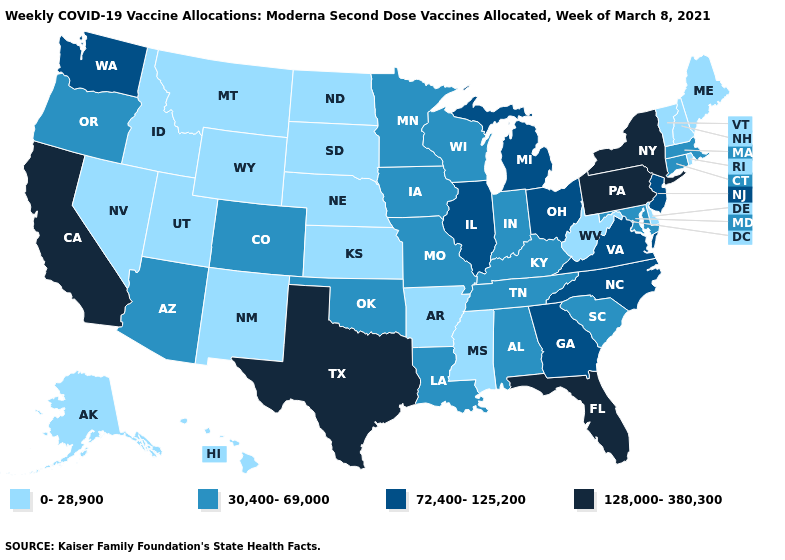Name the states that have a value in the range 30,400-69,000?
Concise answer only. Alabama, Arizona, Colorado, Connecticut, Indiana, Iowa, Kentucky, Louisiana, Maryland, Massachusetts, Minnesota, Missouri, Oklahoma, Oregon, South Carolina, Tennessee, Wisconsin. Does Florida have the highest value in the South?
Answer briefly. Yes. Does the first symbol in the legend represent the smallest category?
Concise answer only. Yes. Which states have the lowest value in the USA?
Be succinct. Alaska, Arkansas, Delaware, Hawaii, Idaho, Kansas, Maine, Mississippi, Montana, Nebraska, Nevada, New Hampshire, New Mexico, North Dakota, Rhode Island, South Dakota, Utah, Vermont, West Virginia, Wyoming. Does the map have missing data?
Keep it brief. No. Name the states that have a value in the range 30,400-69,000?
Answer briefly. Alabama, Arizona, Colorado, Connecticut, Indiana, Iowa, Kentucky, Louisiana, Maryland, Massachusetts, Minnesota, Missouri, Oklahoma, Oregon, South Carolina, Tennessee, Wisconsin. Name the states that have a value in the range 30,400-69,000?
Quick response, please. Alabama, Arizona, Colorado, Connecticut, Indiana, Iowa, Kentucky, Louisiana, Maryland, Massachusetts, Minnesota, Missouri, Oklahoma, Oregon, South Carolina, Tennessee, Wisconsin. Name the states that have a value in the range 30,400-69,000?
Keep it brief. Alabama, Arizona, Colorado, Connecticut, Indiana, Iowa, Kentucky, Louisiana, Maryland, Massachusetts, Minnesota, Missouri, Oklahoma, Oregon, South Carolina, Tennessee, Wisconsin. What is the value of Vermont?
Be succinct. 0-28,900. Does Colorado have the lowest value in the USA?
Write a very short answer. No. Which states have the lowest value in the USA?
Answer briefly. Alaska, Arkansas, Delaware, Hawaii, Idaho, Kansas, Maine, Mississippi, Montana, Nebraska, Nevada, New Hampshire, New Mexico, North Dakota, Rhode Island, South Dakota, Utah, Vermont, West Virginia, Wyoming. What is the value of Arkansas?
Be succinct. 0-28,900. Does Minnesota have the lowest value in the USA?
Answer briefly. No. Name the states that have a value in the range 30,400-69,000?
Write a very short answer. Alabama, Arizona, Colorado, Connecticut, Indiana, Iowa, Kentucky, Louisiana, Maryland, Massachusetts, Minnesota, Missouri, Oklahoma, Oregon, South Carolina, Tennessee, Wisconsin. What is the value of Vermont?
Be succinct. 0-28,900. 